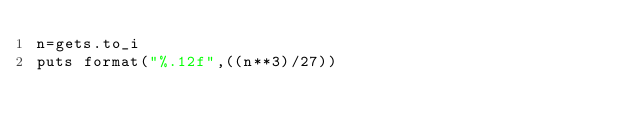Convert code to text. <code><loc_0><loc_0><loc_500><loc_500><_Ruby_>n=gets.to_i
puts format("%.12f",((n**3)/27))
</code> 